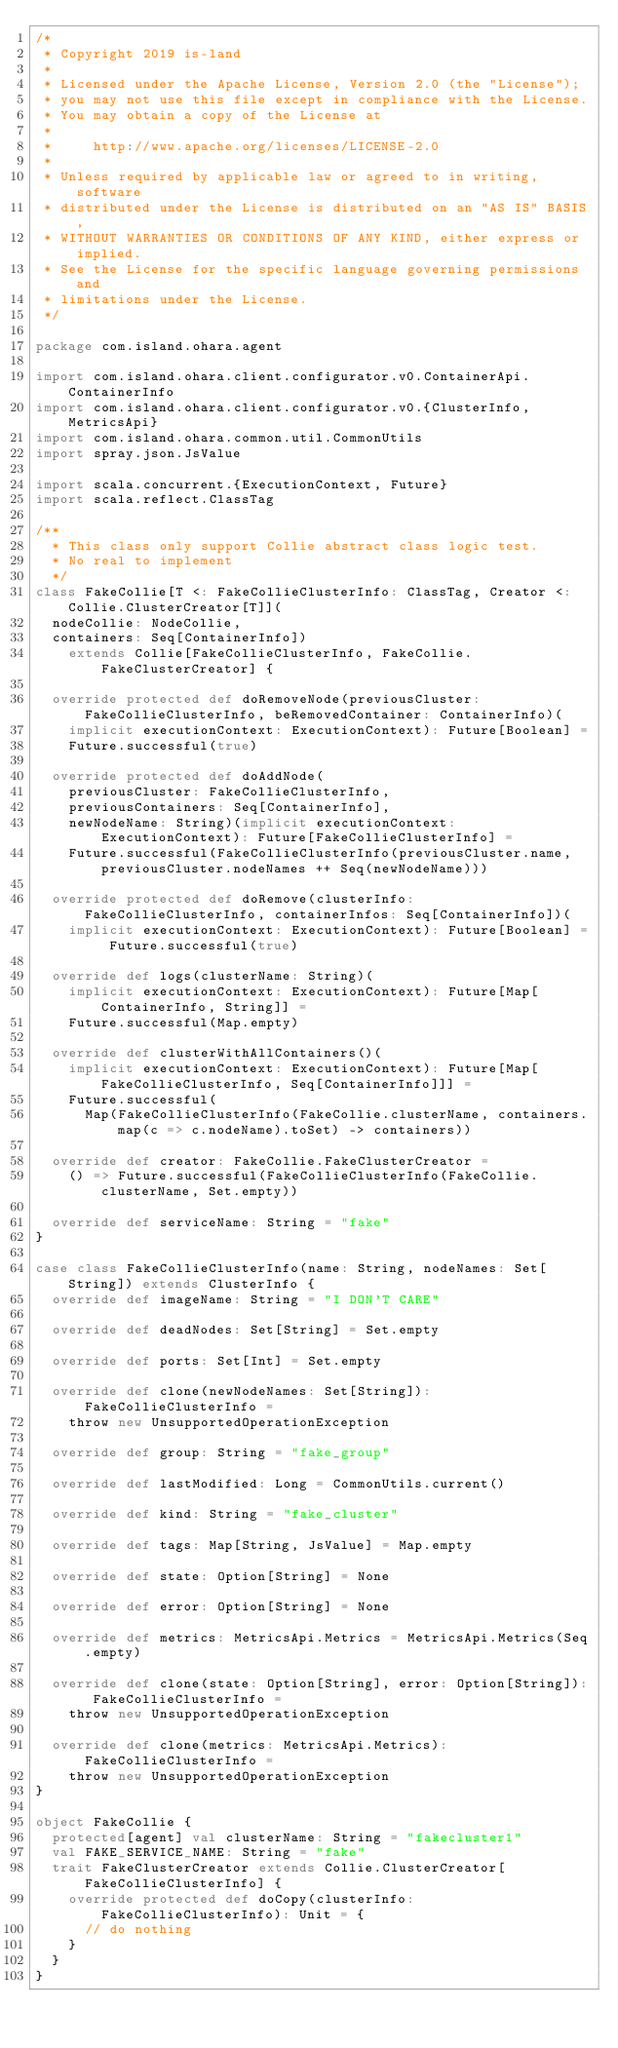<code> <loc_0><loc_0><loc_500><loc_500><_Scala_>/*
 * Copyright 2019 is-land
 *
 * Licensed under the Apache License, Version 2.0 (the "License");
 * you may not use this file except in compliance with the License.
 * You may obtain a copy of the License at
 *
 *     http://www.apache.org/licenses/LICENSE-2.0
 *
 * Unless required by applicable law or agreed to in writing, software
 * distributed under the License is distributed on an "AS IS" BASIS,
 * WITHOUT WARRANTIES OR CONDITIONS OF ANY KIND, either express or implied.
 * See the License for the specific language governing permissions and
 * limitations under the License.
 */

package com.island.ohara.agent

import com.island.ohara.client.configurator.v0.ContainerApi.ContainerInfo
import com.island.ohara.client.configurator.v0.{ClusterInfo, MetricsApi}
import com.island.ohara.common.util.CommonUtils
import spray.json.JsValue

import scala.concurrent.{ExecutionContext, Future}
import scala.reflect.ClassTag

/**
  * This class only support Collie abstract class logic test.
  * No real to implement
  */
class FakeCollie[T <: FakeCollieClusterInfo: ClassTag, Creator <: Collie.ClusterCreator[T]](
  nodeCollie: NodeCollie,
  containers: Seq[ContainerInfo])
    extends Collie[FakeCollieClusterInfo, FakeCollie.FakeClusterCreator] {

  override protected def doRemoveNode(previousCluster: FakeCollieClusterInfo, beRemovedContainer: ContainerInfo)(
    implicit executionContext: ExecutionContext): Future[Boolean] =
    Future.successful(true)

  override protected def doAddNode(
    previousCluster: FakeCollieClusterInfo,
    previousContainers: Seq[ContainerInfo],
    newNodeName: String)(implicit executionContext: ExecutionContext): Future[FakeCollieClusterInfo] =
    Future.successful(FakeCollieClusterInfo(previousCluster.name, previousCluster.nodeNames ++ Seq(newNodeName)))

  override protected def doRemove(clusterInfo: FakeCollieClusterInfo, containerInfos: Seq[ContainerInfo])(
    implicit executionContext: ExecutionContext): Future[Boolean] = Future.successful(true)

  override def logs(clusterName: String)(
    implicit executionContext: ExecutionContext): Future[Map[ContainerInfo, String]] =
    Future.successful(Map.empty)

  override def clusterWithAllContainers()(
    implicit executionContext: ExecutionContext): Future[Map[FakeCollieClusterInfo, Seq[ContainerInfo]]] =
    Future.successful(
      Map(FakeCollieClusterInfo(FakeCollie.clusterName, containers.map(c => c.nodeName).toSet) -> containers))

  override def creator: FakeCollie.FakeClusterCreator =
    () => Future.successful(FakeCollieClusterInfo(FakeCollie.clusterName, Set.empty))

  override def serviceName: String = "fake"
}

case class FakeCollieClusterInfo(name: String, nodeNames: Set[String]) extends ClusterInfo {
  override def imageName: String = "I DON'T CARE"

  override def deadNodes: Set[String] = Set.empty

  override def ports: Set[Int] = Set.empty

  override def clone(newNodeNames: Set[String]): FakeCollieClusterInfo =
    throw new UnsupportedOperationException

  override def group: String = "fake_group"

  override def lastModified: Long = CommonUtils.current()

  override def kind: String = "fake_cluster"

  override def tags: Map[String, JsValue] = Map.empty

  override def state: Option[String] = None

  override def error: Option[String] = None

  override def metrics: MetricsApi.Metrics = MetricsApi.Metrics(Seq.empty)

  override def clone(state: Option[String], error: Option[String]): FakeCollieClusterInfo =
    throw new UnsupportedOperationException

  override def clone(metrics: MetricsApi.Metrics): FakeCollieClusterInfo =
    throw new UnsupportedOperationException
}

object FakeCollie {
  protected[agent] val clusterName: String = "fakecluster1"
  val FAKE_SERVICE_NAME: String = "fake"
  trait FakeClusterCreator extends Collie.ClusterCreator[FakeCollieClusterInfo] {
    override protected def doCopy(clusterInfo: FakeCollieClusterInfo): Unit = {
      // do nothing
    }
  }
}
</code> 